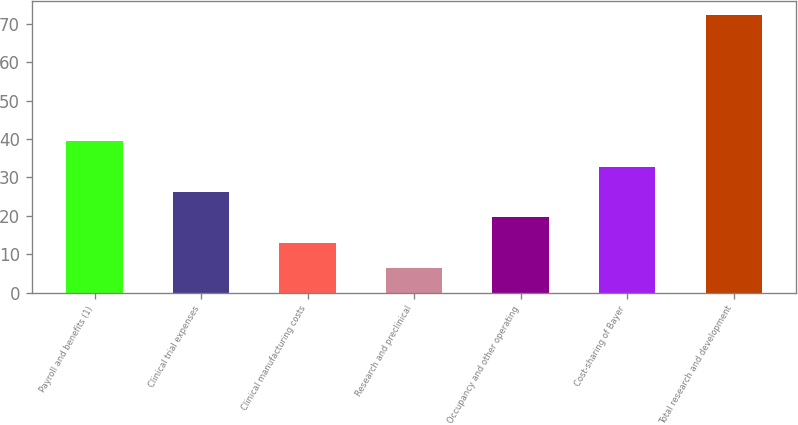<chart> <loc_0><loc_0><loc_500><loc_500><bar_chart><fcel>Payroll and benefits (1)<fcel>Clinical trial expenses<fcel>Clinical manufacturing costs<fcel>Research and preclinical<fcel>Occupancy and other operating<fcel>Cost-sharing of Bayer<fcel>Total research and development<nl><fcel>39.4<fcel>26.2<fcel>13<fcel>6.4<fcel>19.6<fcel>32.8<fcel>72.4<nl></chart> 